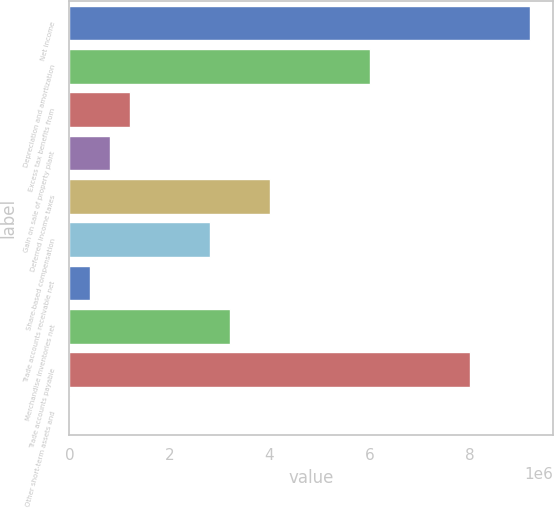<chart> <loc_0><loc_0><loc_500><loc_500><bar_chart><fcel>Net income<fcel>Depreciation and amortization<fcel>Excess tax benefits from<fcel>Gain on sale of property plant<fcel>Deferred income taxes<fcel>Share-based compensation<fcel>Trade accounts receivable net<fcel>Merchandise inventories net<fcel>Trade accounts payable<fcel>Other short-term assets and<nl><fcel>9.21068e+06<fcel>6.0073e+06<fcel>1.20223e+06<fcel>801812<fcel>4.00519e+06<fcel>2.80392e+06<fcel>401389<fcel>3.20435e+06<fcel>8.00942e+06<fcel>967<nl></chart> 